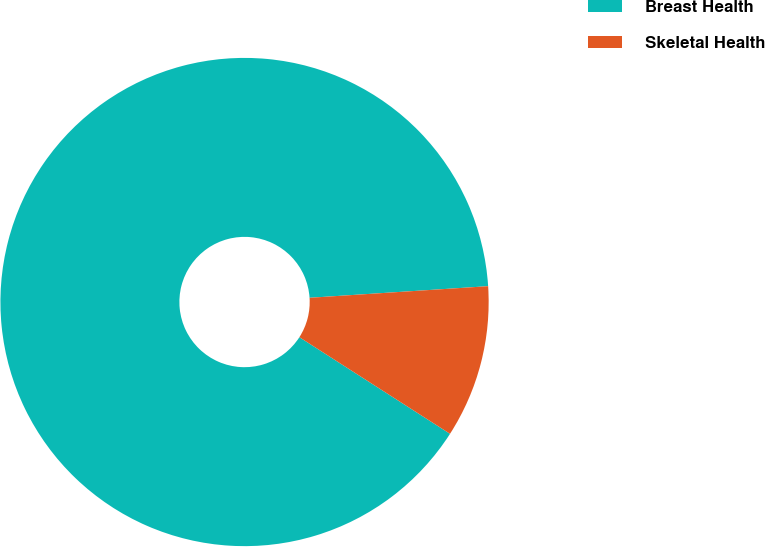Convert chart to OTSL. <chart><loc_0><loc_0><loc_500><loc_500><pie_chart><fcel>Breast Health<fcel>Skeletal Health<nl><fcel>89.89%<fcel>10.11%<nl></chart> 